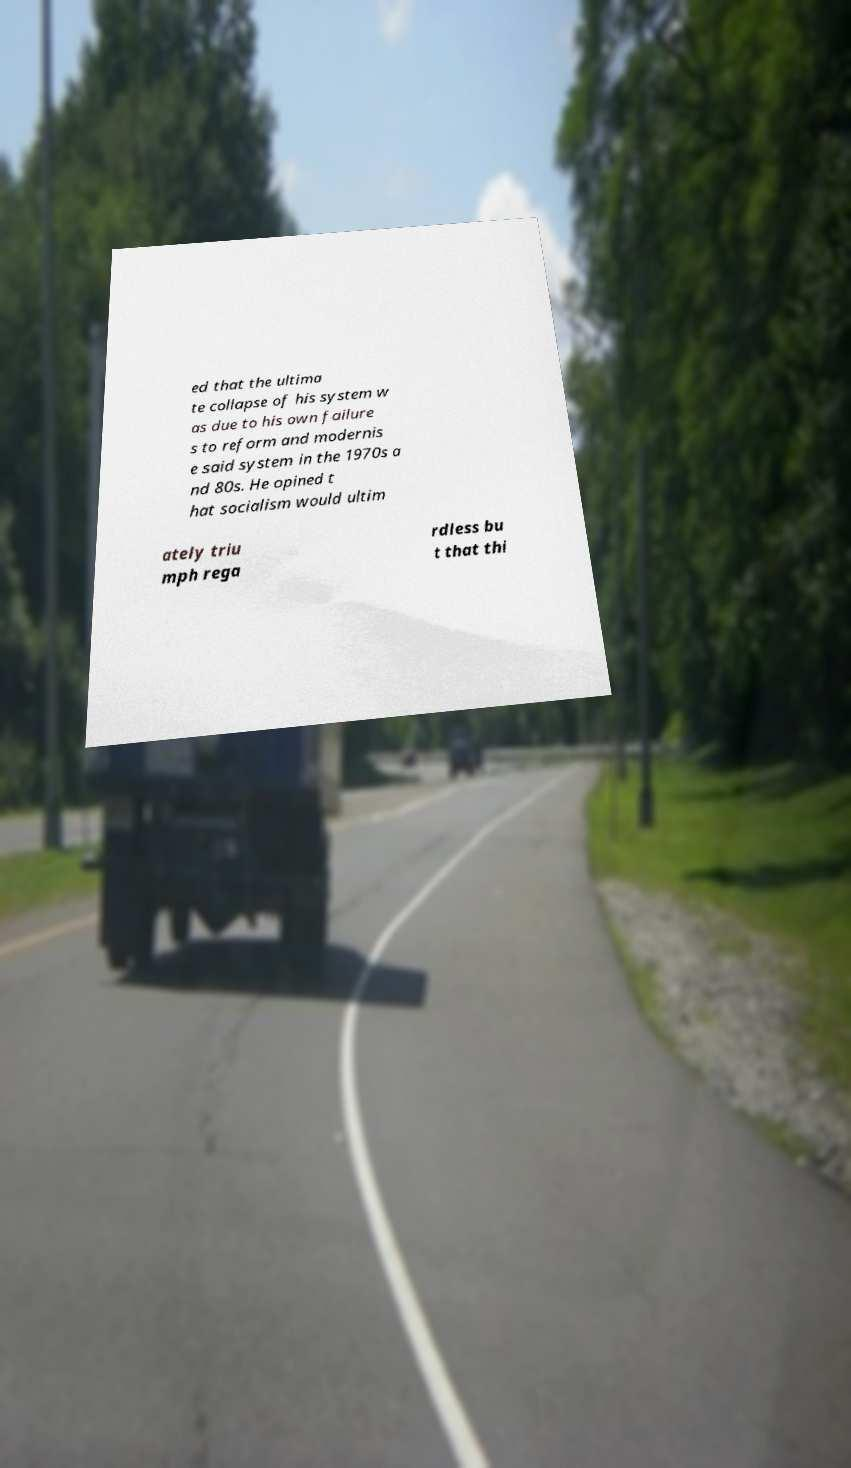There's text embedded in this image that I need extracted. Can you transcribe it verbatim? ed that the ultima te collapse of his system w as due to his own failure s to reform and modernis e said system in the 1970s a nd 80s. He opined t hat socialism would ultim ately triu mph rega rdless bu t that thi 